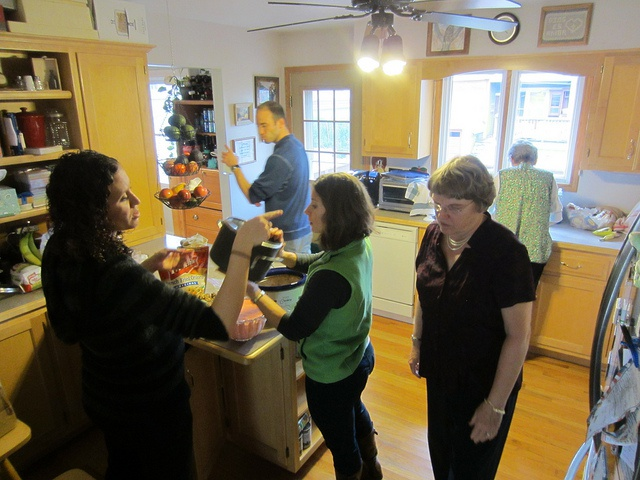Describe the objects in this image and their specific colors. I can see people in gray, black, and maroon tones, people in gray, black, and maroon tones, people in gray, black, and darkgreen tones, refrigerator in gray, darkgray, and black tones, and people in gray, darkgray, tan, and black tones in this image. 